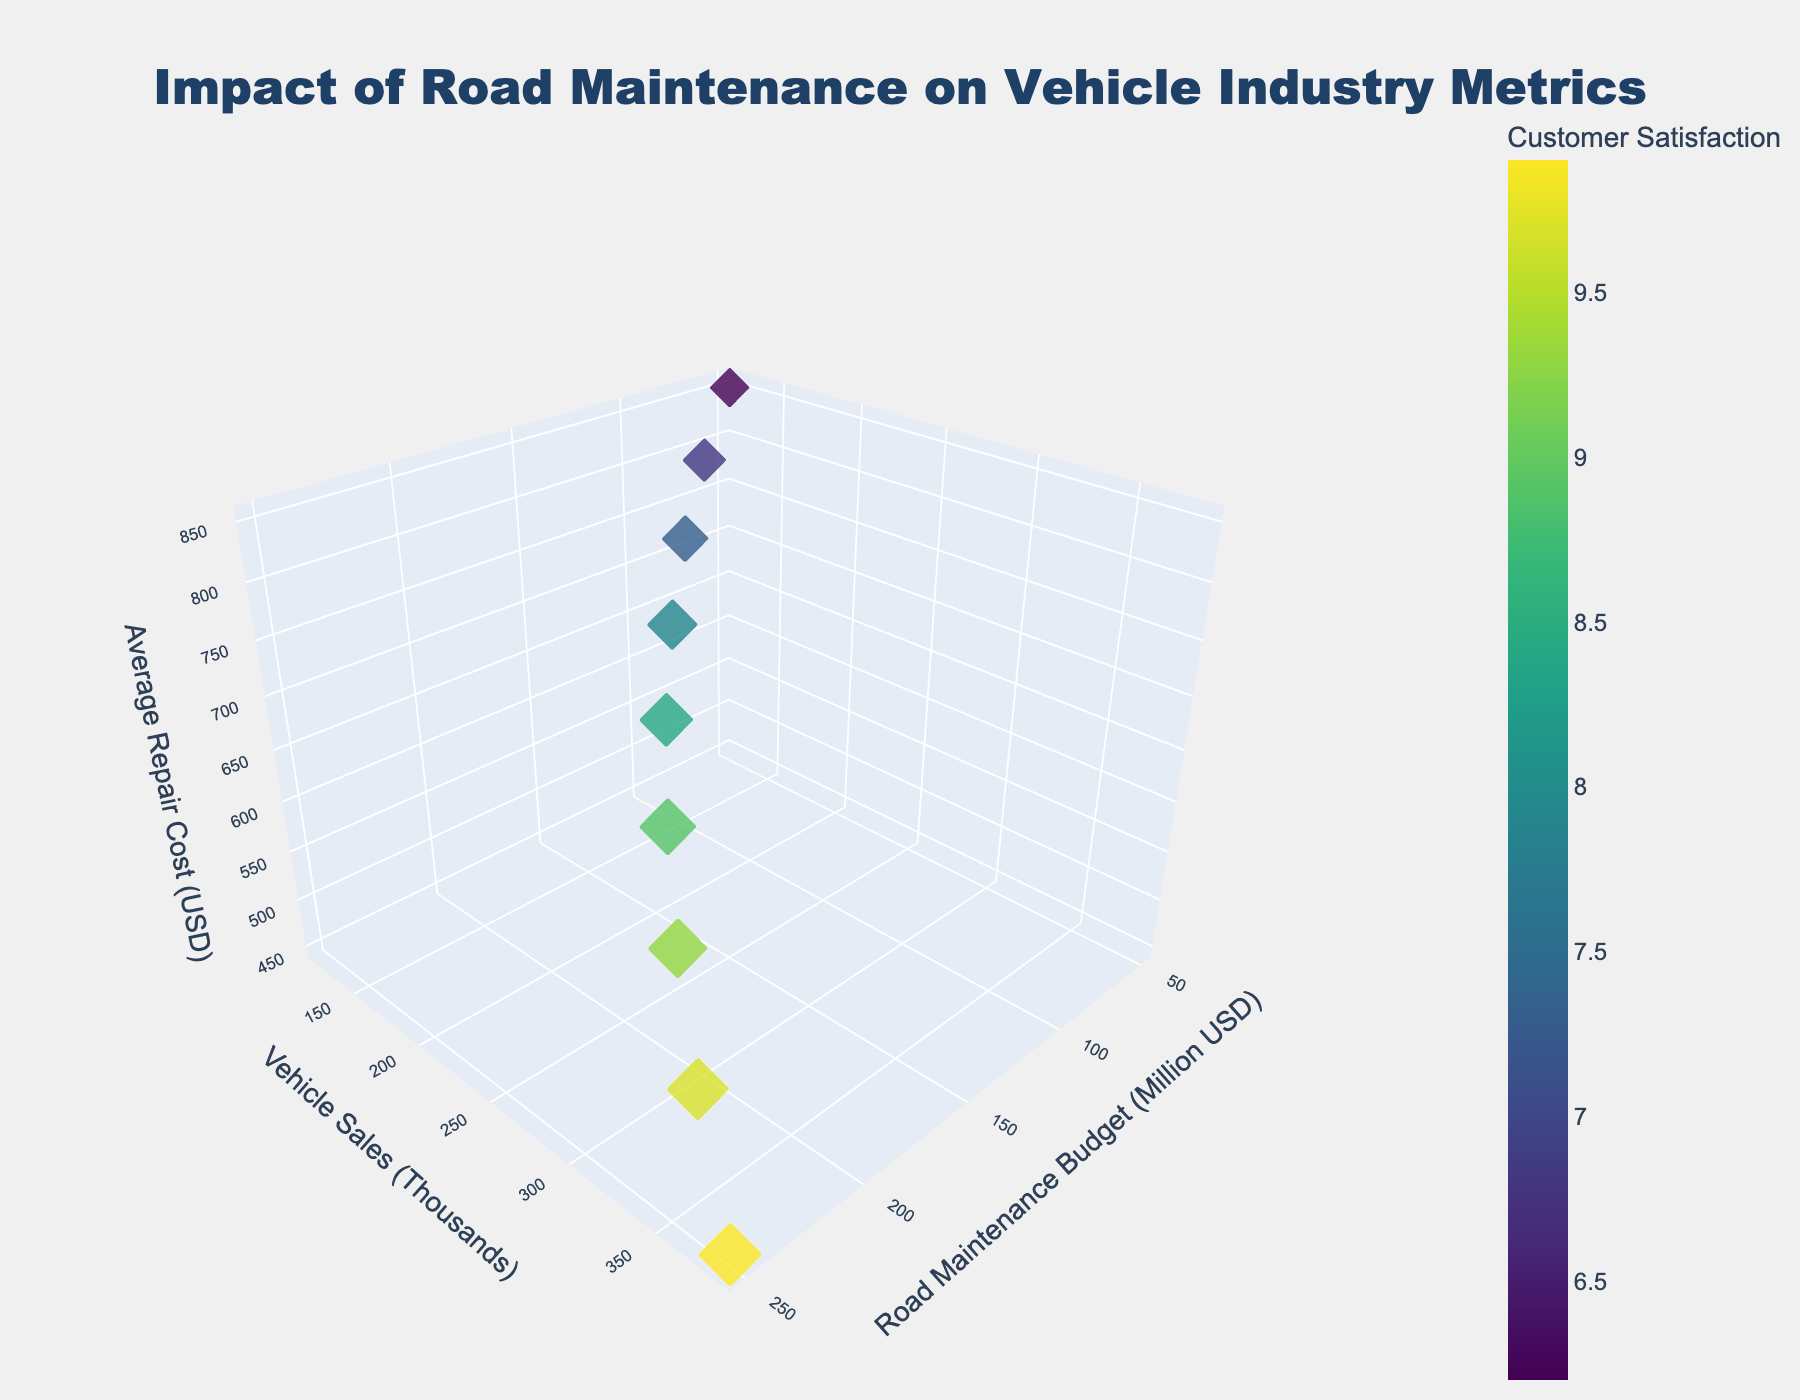How does the customer satisfaction score change with an increase in road maintenance budget? As the road maintenance budget increases, the customer satisfaction score also increases. Points corresponding to higher budget values have larger markers, indicating higher satisfaction scores.
Answer: Increases What is the average vehicle repair cost when the road maintenance budget is $150 million? According to the plot, when the road maintenance budget is $150 million, the average repair cost is $650 USD.
Answer: $650 USD Which data point has the highest vehicle sales, and what is the corresponding road maintenance budget? The data point with the highest vehicle sales (380,000) corresponds to a road maintenance budget of $250 million.
Answer: $250 million How many data points are shown in the figure? The figure displays data for 9 different points, each corresponding to a unique combination of road maintenance budget and vehicle sales, repair costs, and satisfaction score.
Answer: 9 Is there a point where the average repair cost is exactly $700 USD? If so, what are the corresponding vehicle sales and road maintenance budget? Yes, there is a point where the average repair cost is $700 USD. The corresponding vehicle sales are 180,000, and the road maintenance budget is $125 million.
Answer: 180,000 vehicle sales and $125 million budget What trend do you observe in vehicle sales as the road maintenance budget increases? The vehicle sales consistently increase as the road maintenance budget increases, shown by the ascending trend along the y-axis.
Answer: Increases Compare the customer satisfaction score for the budgets of $50 million and $200 million. The customer satisfaction score for a $50 million budget is 6.2, while for a $200 million budget it is 9.3. Therefore, the satisfaction score is higher at $200 million.
Answer: Higher at $200 million What is the vehicle sales difference between the highest and the lowest road maintenance budget? The highest road maintenance budget ($250 million) has vehicle sales of 380,000, while the lowest budget ($50 million) has vehicle sales of 120,000. The difference is 380,000 - 120,000 = 260,000.
Answer: 260,000 Describe the relationship between road maintenance budget and average repair cost. As the road maintenance budget increases, the average repair cost decreases. This is evident by the downward trend along the z-axis as the x-axis increases.
Answer: Decreases 